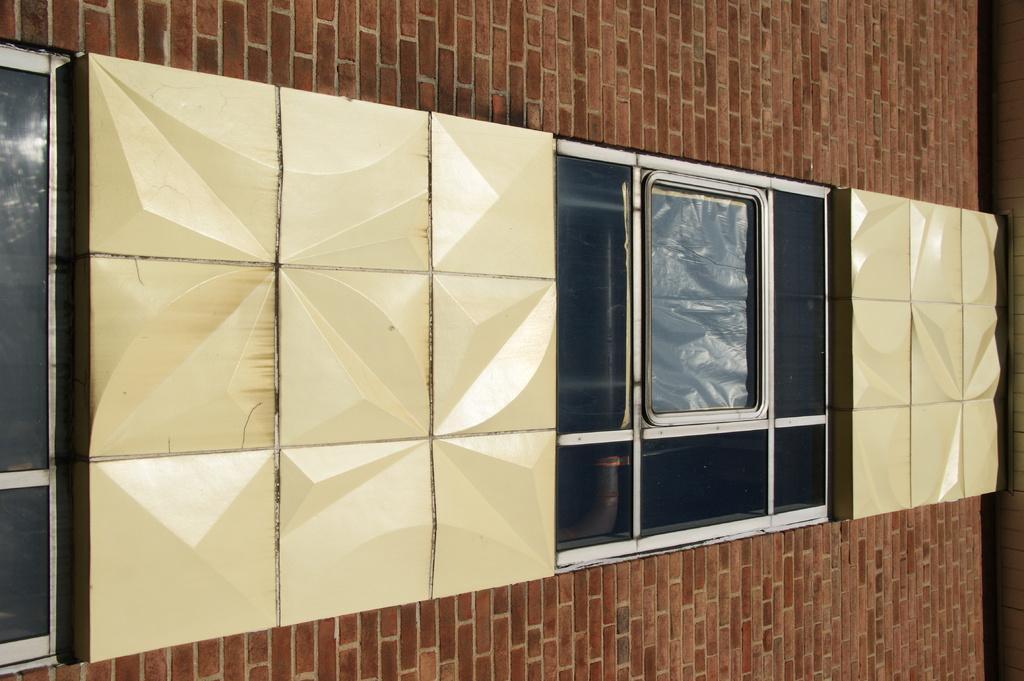Describe this image in one or two sentences. In this picture we can see files, windows and the wall. 